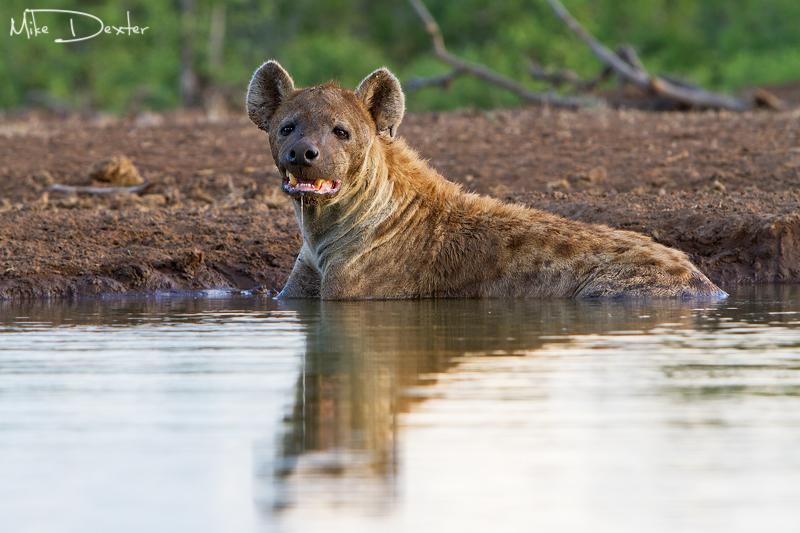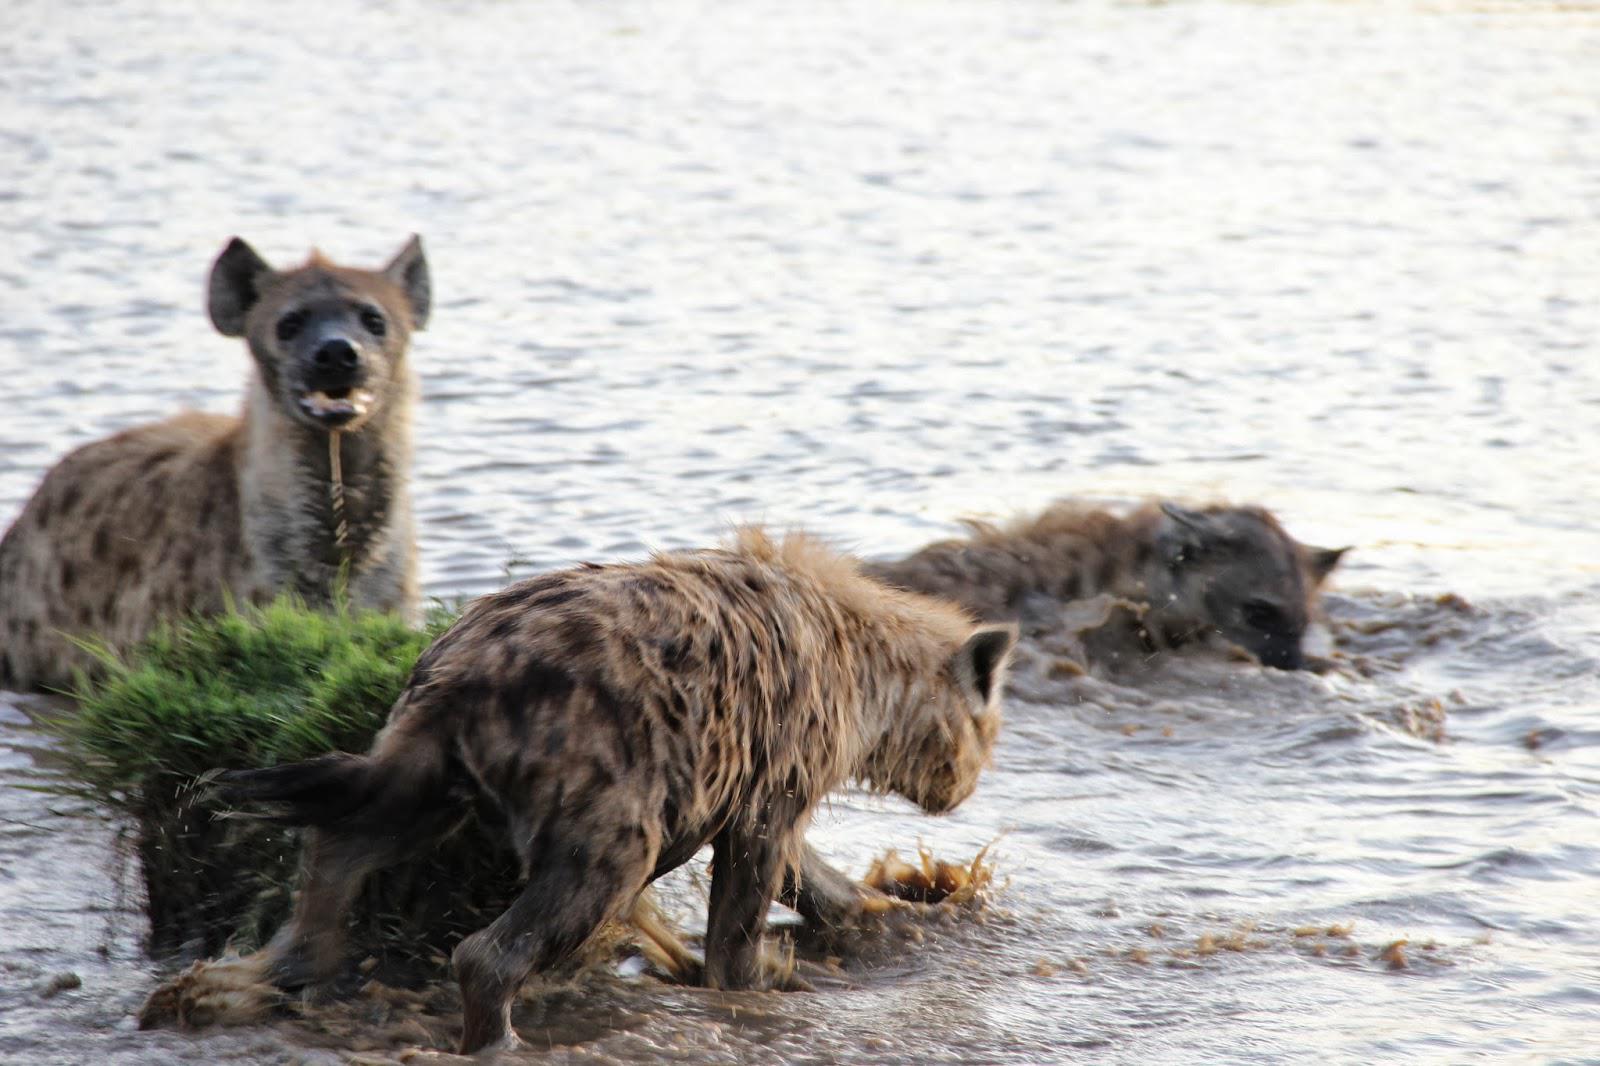The first image is the image on the left, the second image is the image on the right. Evaluate the accuracy of this statement regarding the images: "All hyenas are in the water, and one image shows a single hyena, with its head facing the camera.". Is it true? Answer yes or no. Yes. The first image is the image on the left, the second image is the image on the right. Examine the images to the left and right. Is the description "The right image contains exactly one hyena wading through a body of water." accurate? Answer yes or no. No. The first image is the image on the left, the second image is the image on the right. Assess this claim about the two images: "An image shows at least three hyenas in the water.". Correct or not? Answer yes or no. Yes. The first image is the image on the left, the second image is the image on the right. Given the left and right images, does the statement "There are at least two hyenas in the water in the image on the right." hold true? Answer yes or no. Yes. 